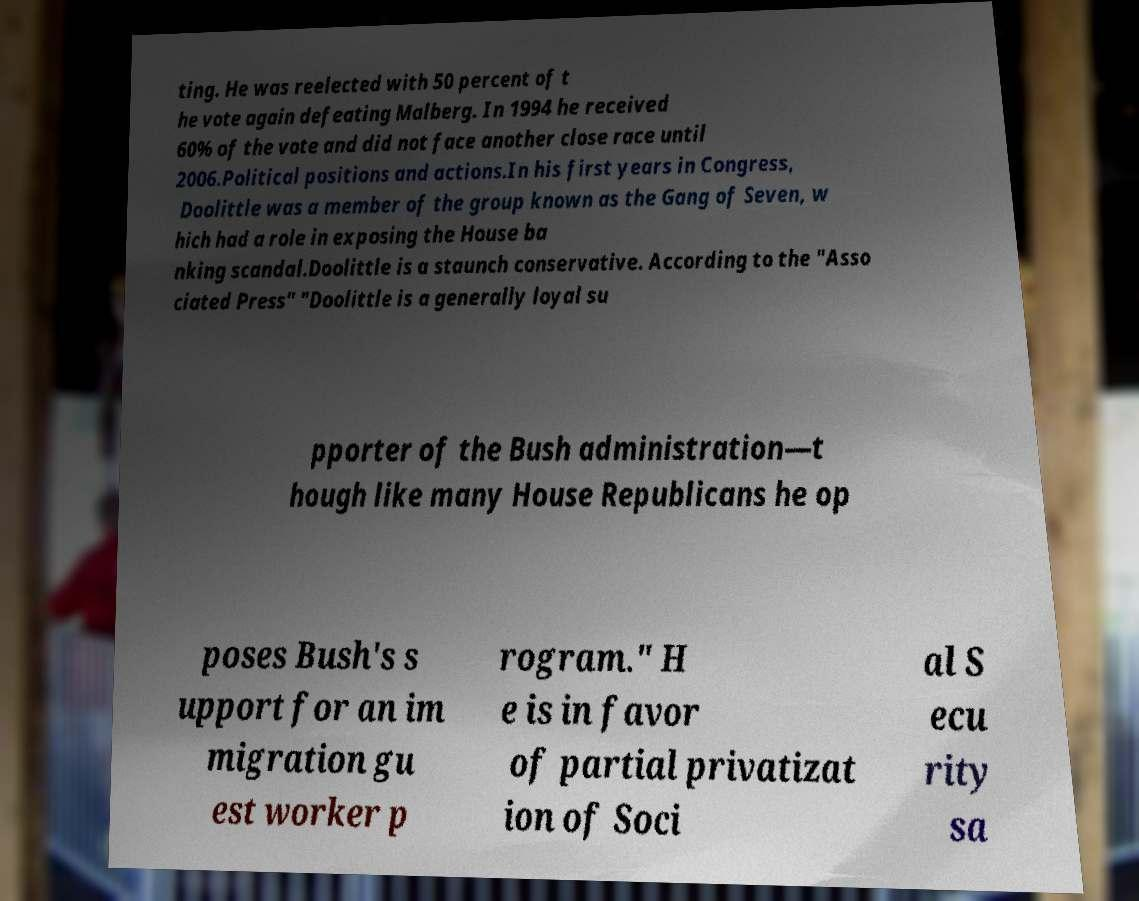Can you read and provide the text displayed in the image?This photo seems to have some interesting text. Can you extract and type it out for me? ting. He was reelected with 50 percent of t he vote again defeating Malberg. In 1994 he received 60% of the vote and did not face another close race until 2006.Political positions and actions.In his first years in Congress, Doolittle was a member of the group known as the Gang of Seven, w hich had a role in exposing the House ba nking scandal.Doolittle is a staunch conservative. According to the "Asso ciated Press" "Doolittle is a generally loyal su pporter of the Bush administration—t hough like many House Republicans he op poses Bush's s upport for an im migration gu est worker p rogram." H e is in favor of partial privatizat ion of Soci al S ecu rity sa 